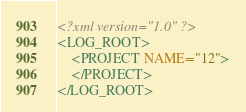Convert code to text. <code><loc_0><loc_0><loc_500><loc_500><_XML_><?xml version="1.0" ?>
<LOG_ROOT>
	<PROJECT NAME="12">
	</PROJECT>
</LOG_ROOT>
</code> 